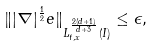Convert formula to latex. <formula><loc_0><loc_0><loc_500><loc_500>\| | \nabla | ^ { \frac { 1 } { 2 } } e \| _ { L _ { t , x } ^ { \frac { 2 ( d + 1 ) } { d + 3 } } ( I ) } \leq \epsilon ,</formula> 